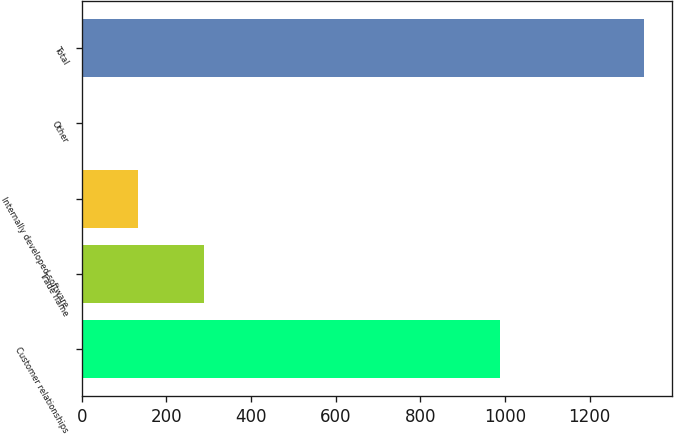Convert chart. <chart><loc_0><loc_0><loc_500><loc_500><bar_chart><fcel>Customer relationships<fcel>Trade name<fcel>Internally developed software<fcel>Other<fcel>Total<nl><fcel>988<fcel>290.1<fcel>133.88<fcel>1.2<fcel>1328<nl></chart> 